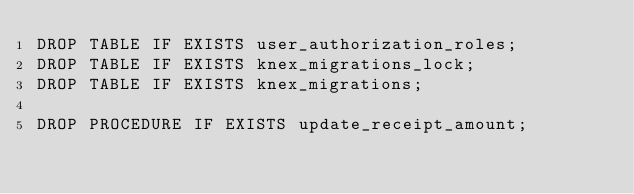Convert code to text. <code><loc_0><loc_0><loc_500><loc_500><_SQL_>DROP TABLE IF EXISTS user_authorization_roles;
DROP TABLE IF EXISTS knex_migrations_lock;
DROP TABLE IF EXISTS knex_migrations;

DROP PROCEDURE IF EXISTS update_receipt_amount;</code> 